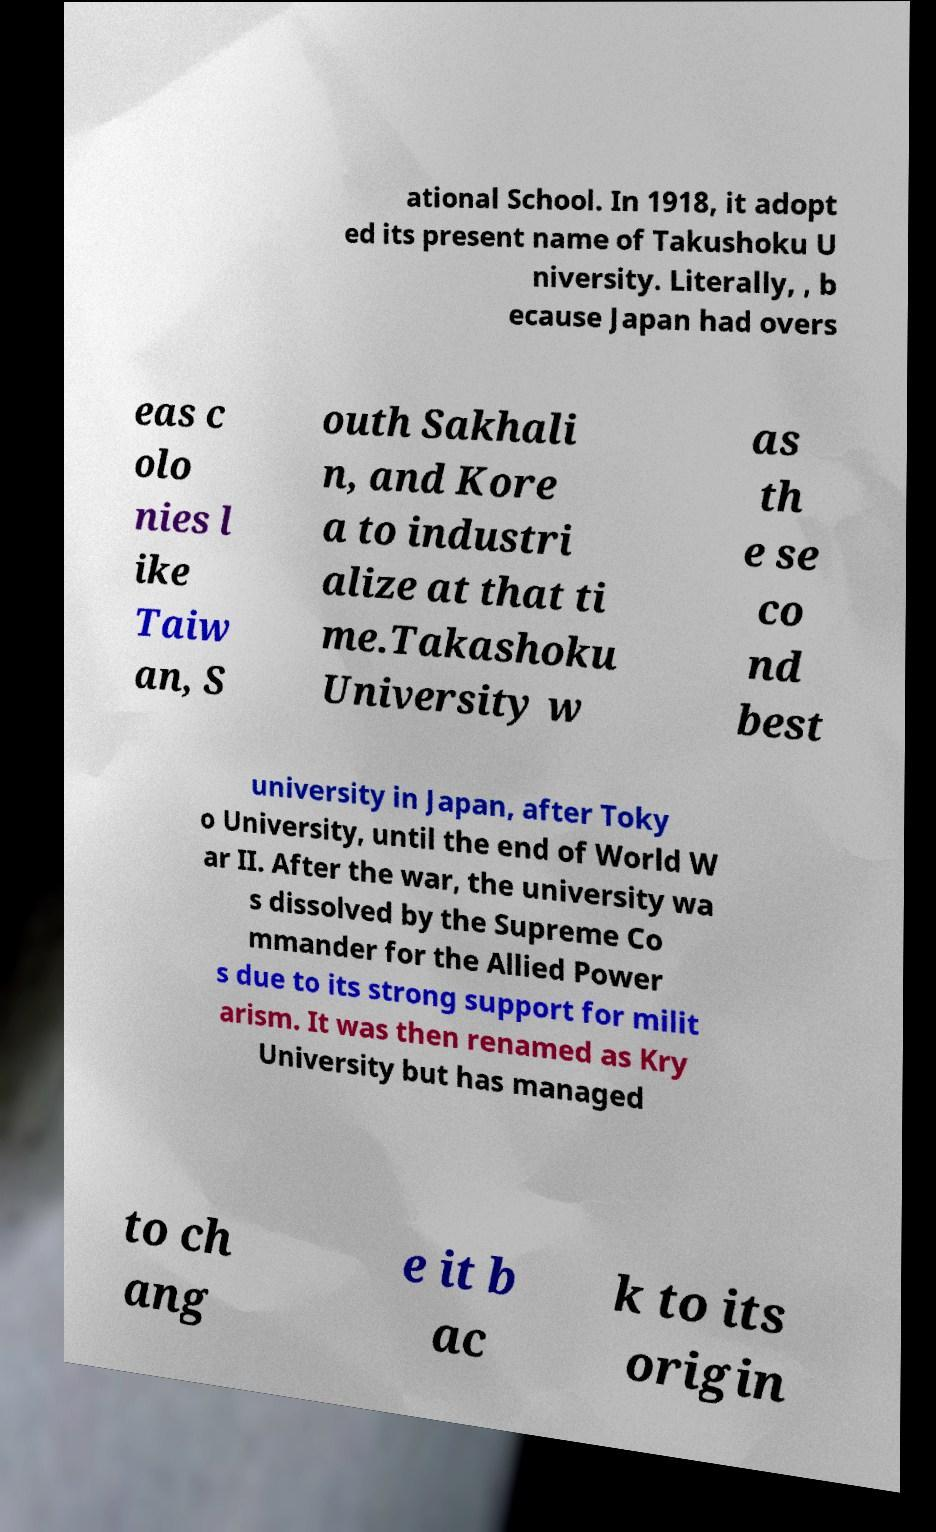I need the written content from this picture converted into text. Can you do that? ational School. In 1918, it adopt ed its present name of Takushoku U niversity. Literally, , b ecause Japan had overs eas c olo nies l ike Taiw an, S outh Sakhali n, and Kore a to industri alize at that ti me.Takashoku University w as th e se co nd best university in Japan, after Toky o University, until the end of World W ar II. After the war, the university wa s dissolved by the Supreme Co mmander for the Allied Power s due to its strong support for milit arism. It was then renamed as Kry University but has managed to ch ang e it b ac k to its origin 